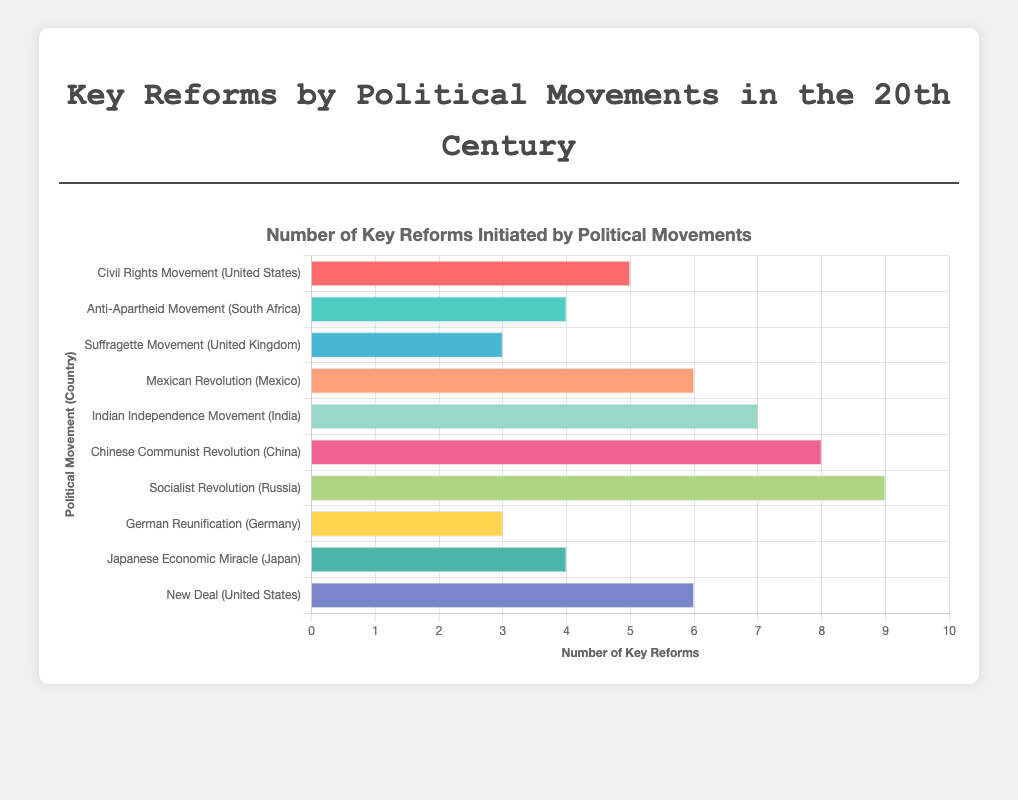Which political movement has the highest number of key reforms? The "Socialist Revolution" in Russia has the highest bar, indicating it has the highest number of key reforms, which is 9.
Answer: Socialist Revolution in Russia How many key reforms were initiated by political movements in the United States collectively? The "Civil Rights Movement" has 5 key reforms and the "New Deal" has 6 key reforms. Summing these gives 5 + 6 = 11.
Answer: 11 Which political movement in Asia initiated more key reforms, the Indian Independence Movement or the Chinese Communist Revolution? The "Chinese Communist Revolution" has 8 key reforms, while the "Indian Independence Movement" has 7 key reforms. 8 is greater than 7.
Answer: Chinese Communist Revolution Which political movements have the same number of key reforms? Both "Suffragette Movement" (United Kingdom) and "German Reunification" (Germany) have 3 key reforms each. Similarly, "Anti-Apartheid Movement" (South Africa) and "Japanese Economic Miracle" (Japan) each have 4 key reforms.
Answer: Suffragette Movement (United Kingdom) and German Reunification (Germany); Anti-Apartheid Movement (South Africa) and Japanese Economic Miracle (Japan) What is the difference in the number of key reforms between the Mexican Revolution and the New Deal? The "Mexican Revolution" has 6 key reforms, while the "New Deal" has 6 key reforms. The difference is 6 - 6 = 0.
Answer: 0 What is the range of the number of key reforms initiated by the political movements? The smallest number of key reforms is 3 (Suffragette Movement and German Reunification), and the largest is 9 (Socialist Revolution). The range is 9 - 3 = 6.
Answer: 6 What is the total number of key reforms initiated by political movements in Africa? The "Anti-Apartheid Movement" in South Africa is the only African political movement listed, and it initiated 4 key reforms.
Answer: 4 Which movement had fewer key reforms: the Civil Rights Movement or the Suffragette Movement? The "Civil Rights Movement" in the United States has 5 key reforms while the "Suffragette Movement" in the United Kingdom has 3 key reforms. 3 is less than 5.
Answer: Suffragette Movement How many more key reforms did the Socialist Revolution initiate compared to the Anti-Apartheid Movement? The "Socialist Revolution" has 9 key reforms, and the "Anti-Apartheid Movement" has 4 key reforms. The difference is 9 - 4 = 5.
Answer: 5 Which political movements initiate more than 5 key reforms? Movements with more than 5 key reforms are "Socialist Revolution" (9), "Chinese Communist Revolution" (8), "Indian Independence Movement" (7), "Mexican Revolution" (6), and "New Deal" (6).
Answer: Socialist Revolution, Chinese Communist Revolution, Indian Independence Movement, Mexican Revolution, New Deal 